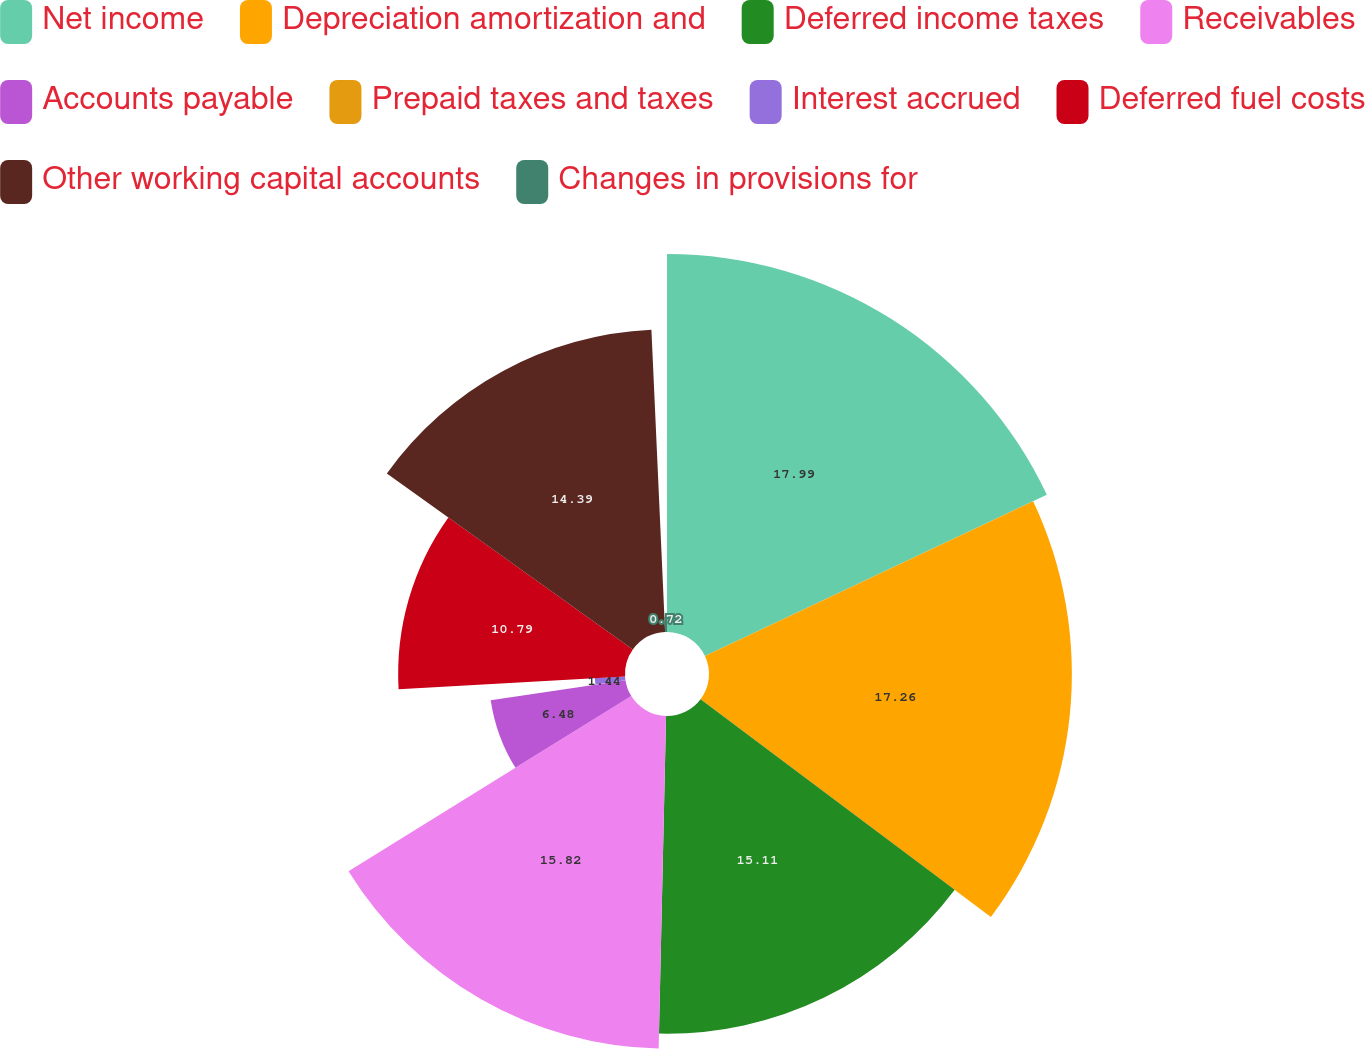Convert chart to OTSL. <chart><loc_0><loc_0><loc_500><loc_500><pie_chart><fcel>Net income<fcel>Depreciation amortization and<fcel>Deferred income taxes<fcel>Receivables<fcel>Accounts payable<fcel>Prepaid taxes and taxes<fcel>Interest accrued<fcel>Deferred fuel costs<fcel>Other working capital accounts<fcel>Changes in provisions for<nl><fcel>17.98%<fcel>17.26%<fcel>15.11%<fcel>15.82%<fcel>6.48%<fcel>0.0%<fcel>1.44%<fcel>10.79%<fcel>14.39%<fcel>0.72%<nl></chart> 